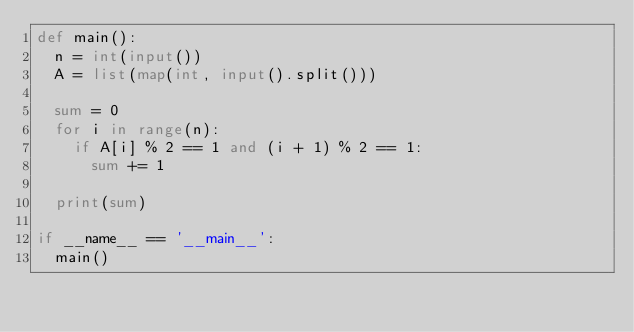<code> <loc_0><loc_0><loc_500><loc_500><_Python_>def main():
  n = int(input())
  A = list(map(int, input().split()))

  sum = 0
  for i in range(n):
    if A[i] % 2 == 1 and (i + 1) % 2 == 1:
      sum += 1

  print(sum)

if __name__ == '__main__':
  main()
</code> 